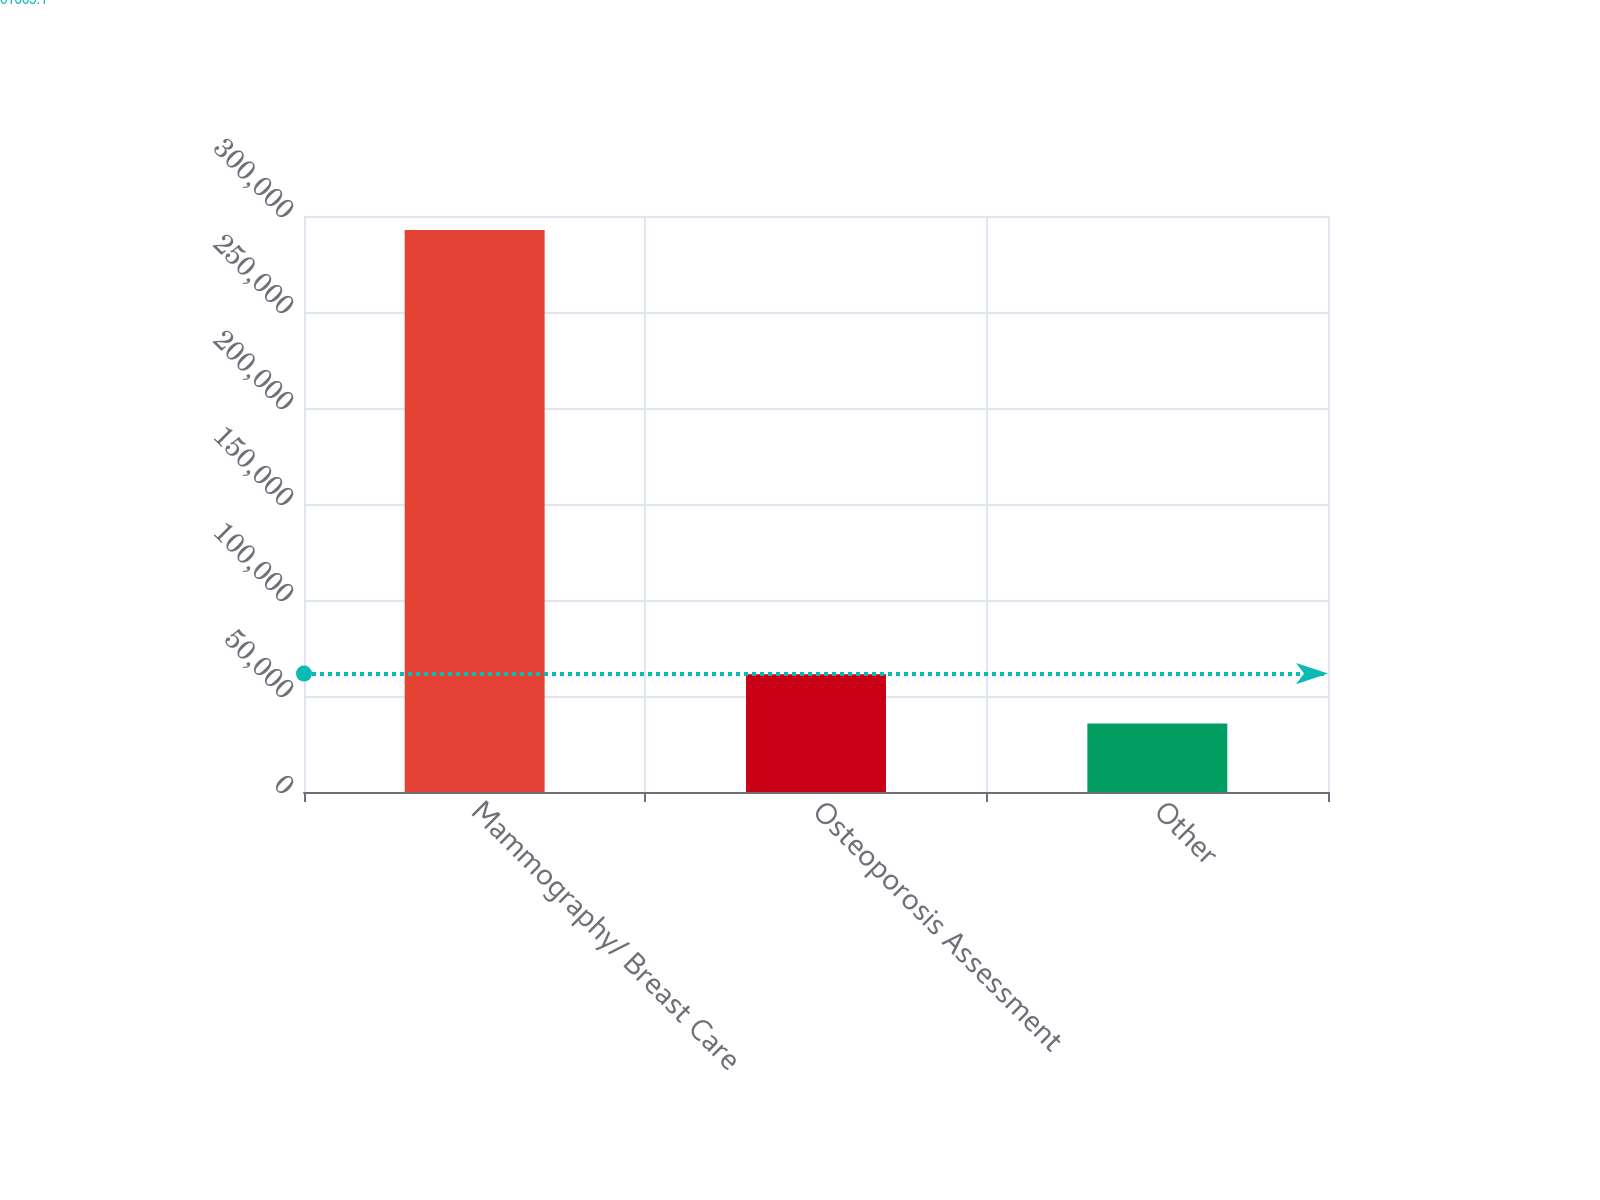Convert chart to OTSL. <chart><loc_0><loc_0><loc_500><loc_500><bar_chart><fcel>Mammography/ Breast Care<fcel>Osteoporosis Assessment<fcel>Other<nl><fcel>292773<fcel>61372.2<fcel>35661<nl></chart> 